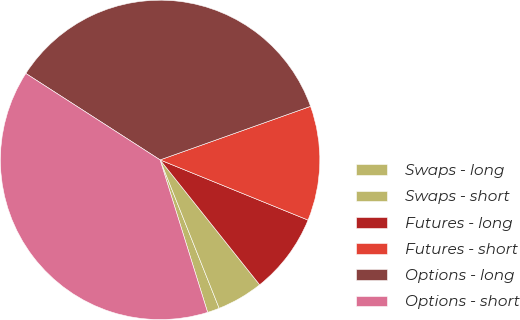<chart> <loc_0><loc_0><loc_500><loc_500><pie_chart><fcel>Swaps - long<fcel>Swaps - short<fcel>Futures - long<fcel>Futures - short<fcel>Options - long<fcel>Options - short<nl><fcel>1.22%<fcel>4.68%<fcel>8.14%<fcel>11.59%<fcel>35.45%<fcel>38.91%<nl></chart> 